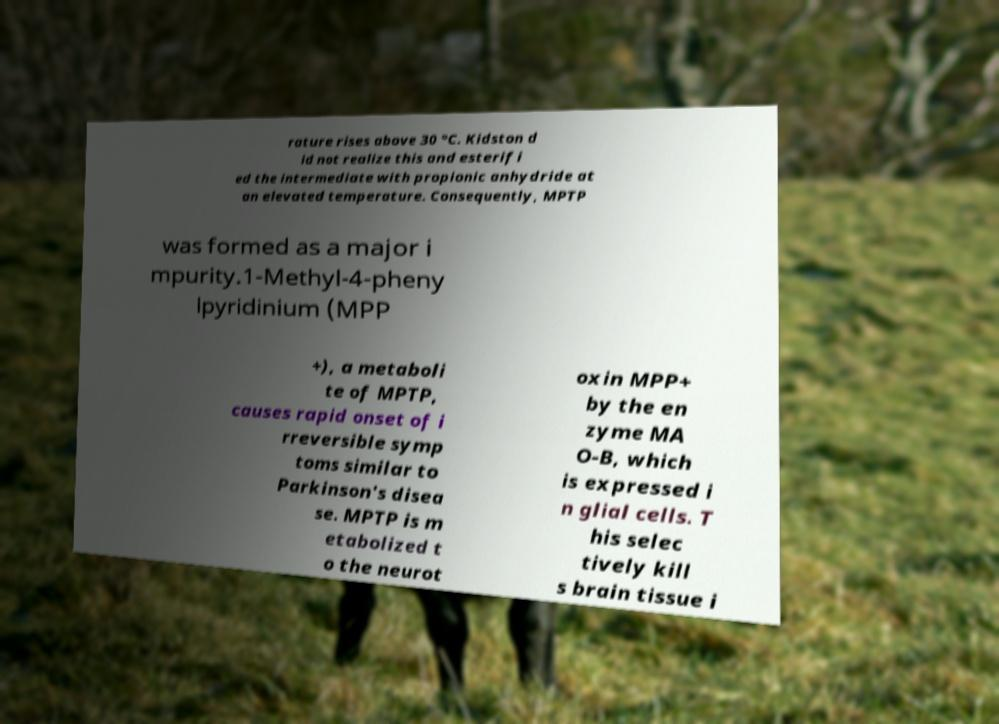There's text embedded in this image that I need extracted. Can you transcribe it verbatim? rature rises above 30 °C. Kidston d id not realize this and esterifi ed the intermediate with propionic anhydride at an elevated temperature. Consequently, MPTP was formed as a major i mpurity.1-Methyl-4-pheny lpyridinium (MPP +), a metaboli te of MPTP, causes rapid onset of i rreversible symp toms similar to Parkinson's disea se. MPTP is m etabolized t o the neurot oxin MPP+ by the en zyme MA O-B, which is expressed i n glial cells. T his selec tively kill s brain tissue i 